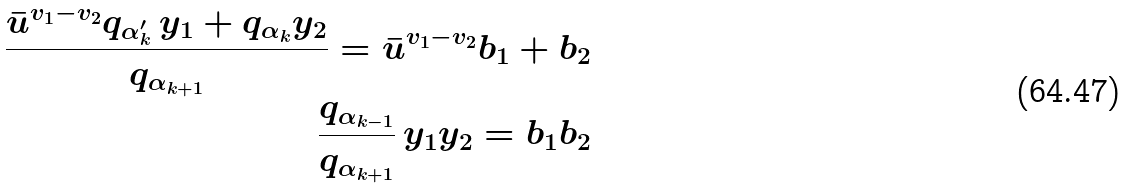Convert formula to latex. <formula><loc_0><loc_0><loc_500><loc_500>\frac { \bar { u } ^ { v _ { 1 } - v _ { 2 } } q _ { \alpha _ { k } ^ { \prime } } \, y _ { 1 } + q _ { \alpha _ { k } } y _ { 2 } } { q _ { \alpha _ { k + 1 } } } = \bar { u } ^ { v _ { 1 } - v _ { 2 } } b _ { 1 } + b _ { 2 } \\ \frac { q _ { \alpha _ { k - 1 } } } { q _ { \alpha _ { k + 1 } } } \, y _ { 1 } y _ { 2 } = b _ { 1 } b _ { 2 }</formula> 